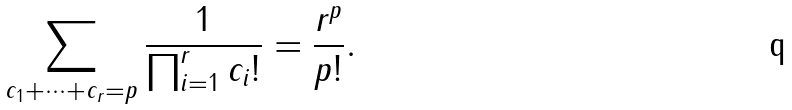Convert formula to latex. <formula><loc_0><loc_0><loc_500><loc_500>\sum _ { c _ { 1 } + \dots + c _ { r } = p } \frac { 1 } { \prod _ { i = 1 } ^ { r } c _ { i } ! } = \frac { r ^ { p } } { p ! } .</formula> 